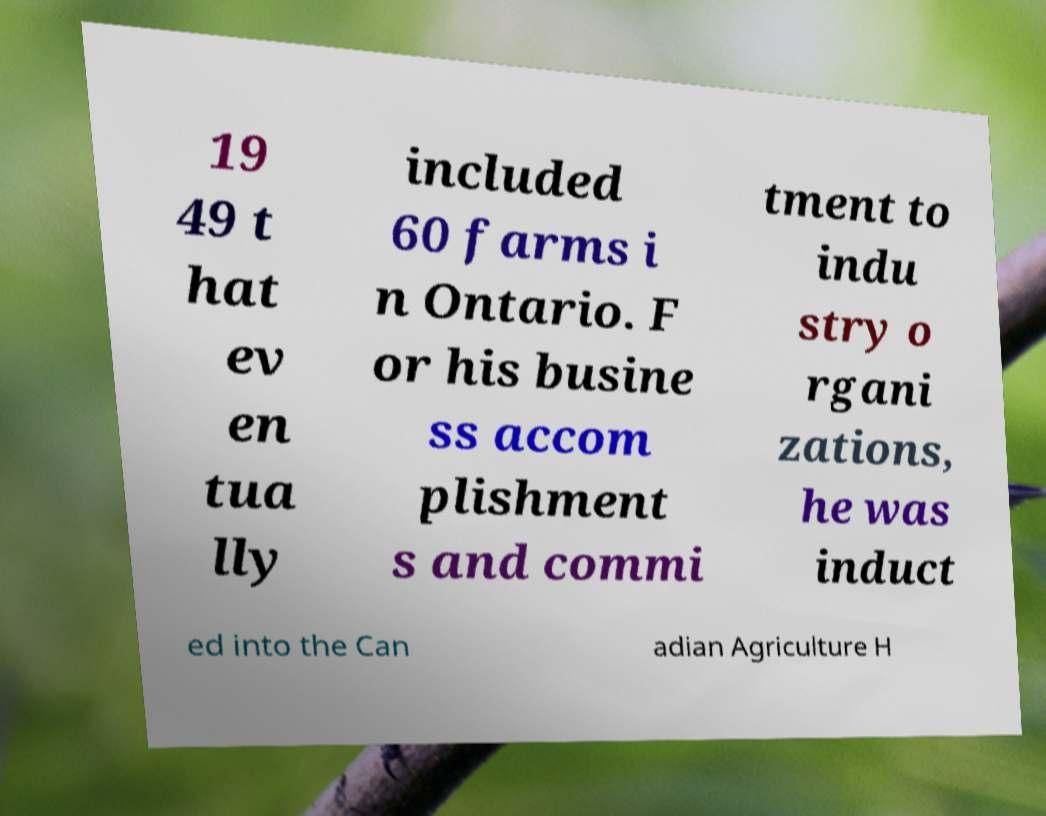Can you read and provide the text displayed in the image?This photo seems to have some interesting text. Can you extract and type it out for me? 19 49 t hat ev en tua lly included 60 farms i n Ontario. F or his busine ss accom plishment s and commi tment to indu stry o rgani zations, he was induct ed into the Can adian Agriculture H 